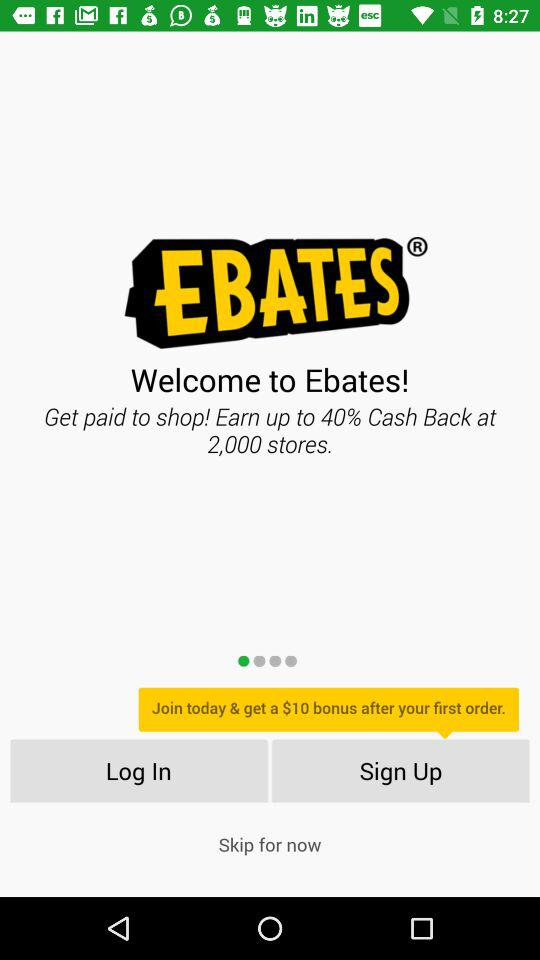What is the app name? The app name is "EBATES". 